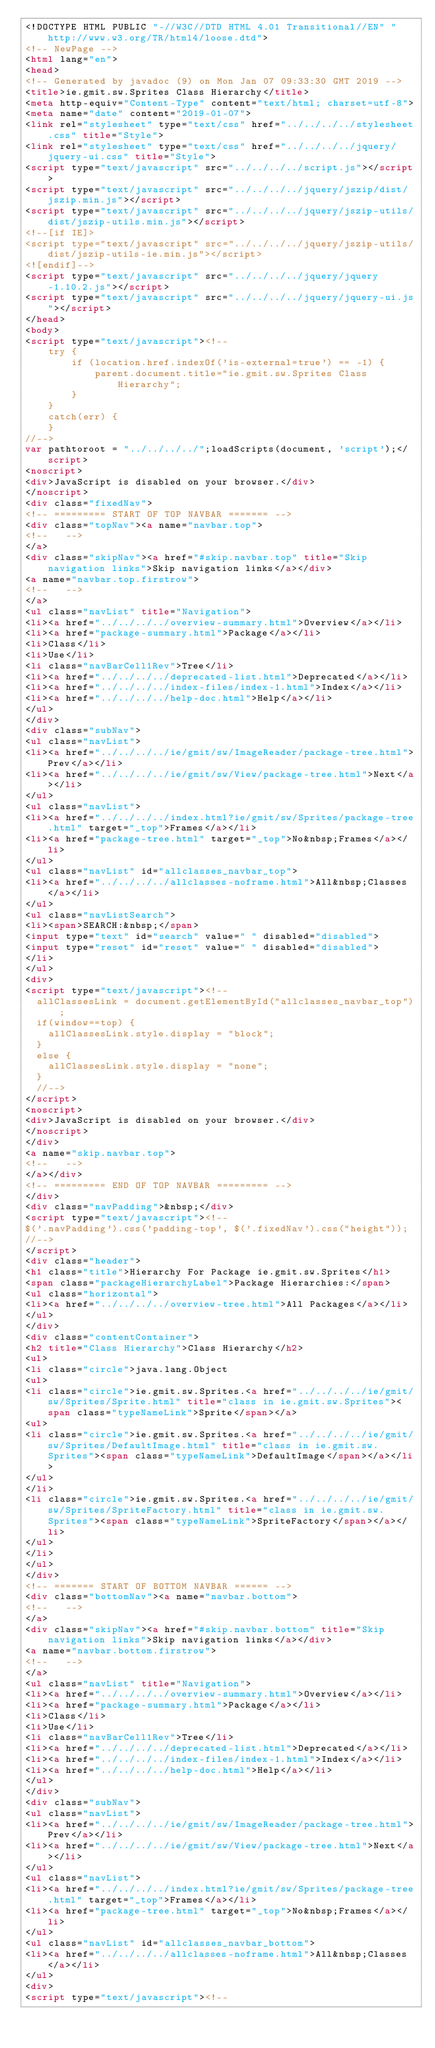<code> <loc_0><loc_0><loc_500><loc_500><_HTML_><!DOCTYPE HTML PUBLIC "-//W3C//DTD HTML 4.01 Transitional//EN" "http://www.w3.org/TR/html4/loose.dtd">
<!-- NewPage -->
<html lang="en">
<head>
<!-- Generated by javadoc (9) on Mon Jan 07 09:33:30 GMT 2019 -->
<title>ie.gmit.sw.Sprites Class Hierarchy</title>
<meta http-equiv="Content-Type" content="text/html; charset=utf-8">
<meta name="date" content="2019-01-07">
<link rel="stylesheet" type="text/css" href="../../../../stylesheet.css" title="Style">
<link rel="stylesheet" type="text/css" href="../../../../jquery/jquery-ui.css" title="Style">
<script type="text/javascript" src="../../../../script.js"></script>
<script type="text/javascript" src="../../../../jquery/jszip/dist/jszip.min.js"></script>
<script type="text/javascript" src="../../../../jquery/jszip-utils/dist/jszip-utils.min.js"></script>
<!--[if IE]>
<script type="text/javascript" src="../../../../jquery/jszip-utils/dist/jszip-utils-ie.min.js"></script>
<![endif]-->
<script type="text/javascript" src="../../../../jquery/jquery-1.10.2.js"></script>
<script type="text/javascript" src="../../../../jquery/jquery-ui.js"></script>
</head>
<body>
<script type="text/javascript"><!--
    try {
        if (location.href.indexOf('is-external=true') == -1) {
            parent.document.title="ie.gmit.sw.Sprites Class Hierarchy";
        }
    }
    catch(err) {
    }
//-->
var pathtoroot = "../../../../";loadScripts(document, 'script');</script>
<noscript>
<div>JavaScript is disabled on your browser.</div>
</noscript>
<div class="fixedNav">
<!-- ========= START OF TOP NAVBAR ======= -->
<div class="topNav"><a name="navbar.top">
<!--   -->
</a>
<div class="skipNav"><a href="#skip.navbar.top" title="Skip navigation links">Skip navigation links</a></div>
<a name="navbar.top.firstrow">
<!--   -->
</a>
<ul class="navList" title="Navigation">
<li><a href="../../../../overview-summary.html">Overview</a></li>
<li><a href="package-summary.html">Package</a></li>
<li>Class</li>
<li>Use</li>
<li class="navBarCell1Rev">Tree</li>
<li><a href="../../../../deprecated-list.html">Deprecated</a></li>
<li><a href="../../../../index-files/index-1.html">Index</a></li>
<li><a href="../../../../help-doc.html">Help</a></li>
</ul>
</div>
<div class="subNav">
<ul class="navList">
<li><a href="../../../../ie/gmit/sw/ImageReader/package-tree.html">Prev</a></li>
<li><a href="../../../../ie/gmit/sw/View/package-tree.html">Next</a></li>
</ul>
<ul class="navList">
<li><a href="../../../../index.html?ie/gmit/sw/Sprites/package-tree.html" target="_top">Frames</a></li>
<li><a href="package-tree.html" target="_top">No&nbsp;Frames</a></li>
</ul>
<ul class="navList" id="allclasses_navbar_top">
<li><a href="../../../../allclasses-noframe.html">All&nbsp;Classes</a></li>
</ul>
<ul class="navListSearch">
<li><span>SEARCH:&nbsp;</span>
<input type="text" id="search" value=" " disabled="disabled">
<input type="reset" id="reset" value=" " disabled="disabled">
</li>
</ul>
<div>
<script type="text/javascript"><!--
  allClassesLink = document.getElementById("allclasses_navbar_top");
  if(window==top) {
    allClassesLink.style.display = "block";
  }
  else {
    allClassesLink.style.display = "none";
  }
  //-->
</script>
<noscript>
<div>JavaScript is disabled on your browser.</div>
</noscript>
</div>
<a name="skip.navbar.top">
<!--   -->
</a></div>
<!-- ========= END OF TOP NAVBAR ========= -->
</div>
<div class="navPadding">&nbsp;</div>
<script type="text/javascript"><!--
$('.navPadding').css('padding-top', $('.fixedNav').css("height"));
//-->
</script>
<div class="header">
<h1 class="title">Hierarchy For Package ie.gmit.sw.Sprites</h1>
<span class="packageHierarchyLabel">Package Hierarchies:</span>
<ul class="horizontal">
<li><a href="../../../../overview-tree.html">All Packages</a></li>
</ul>
</div>
<div class="contentContainer">
<h2 title="Class Hierarchy">Class Hierarchy</h2>
<ul>
<li class="circle">java.lang.Object
<ul>
<li class="circle">ie.gmit.sw.Sprites.<a href="../../../../ie/gmit/sw/Sprites/Sprite.html" title="class in ie.gmit.sw.Sprites"><span class="typeNameLink">Sprite</span></a>
<ul>
<li class="circle">ie.gmit.sw.Sprites.<a href="../../../../ie/gmit/sw/Sprites/DefaultImage.html" title="class in ie.gmit.sw.Sprites"><span class="typeNameLink">DefaultImage</span></a></li>
</ul>
</li>
<li class="circle">ie.gmit.sw.Sprites.<a href="../../../../ie/gmit/sw/Sprites/SpriteFactory.html" title="class in ie.gmit.sw.Sprites"><span class="typeNameLink">SpriteFactory</span></a></li>
</ul>
</li>
</ul>
</div>
<!-- ======= START OF BOTTOM NAVBAR ====== -->
<div class="bottomNav"><a name="navbar.bottom">
<!--   -->
</a>
<div class="skipNav"><a href="#skip.navbar.bottom" title="Skip navigation links">Skip navigation links</a></div>
<a name="navbar.bottom.firstrow">
<!--   -->
</a>
<ul class="navList" title="Navigation">
<li><a href="../../../../overview-summary.html">Overview</a></li>
<li><a href="package-summary.html">Package</a></li>
<li>Class</li>
<li>Use</li>
<li class="navBarCell1Rev">Tree</li>
<li><a href="../../../../deprecated-list.html">Deprecated</a></li>
<li><a href="../../../../index-files/index-1.html">Index</a></li>
<li><a href="../../../../help-doc.html">Help</a></li>
</ul>
</div>
<div class="subNav">
<ul class="navList">
<li><a href="../../../../ie/gmit/sw/ImageReader/package-tree.html">Prev</a></li>
<li><a href="../../../../ie/gmit/sw/View/package-tree.html">Next</a></li>
</ul>
<ul class="navList">
<li><a href="../../../../index.html?ie/gmit/sw/Sprites/package-tree.html" target="_top">Frames</a></li>
<li><a href="package-tree.html" target="_top">No&nbsp;Frames</a></li>
</ul>
<ul class="navList" id="allclasses_navbar_bottom">
<li><a href="../../../../allclasses-noframe.html">All&nbsp;Classes</a></li>
</ul>
<div>
<script type="text/javascript"><!--</code> 